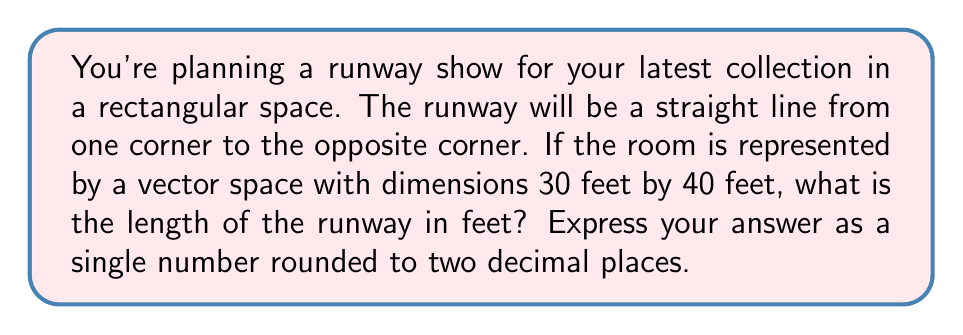Give your solution to this math problem. Let's approach this step-by-step using vector math:

1) First, we need to represent the room as a vector. The dimensions are 30 feet by 40 feet, so we can represent this as a vector:

   $\vec{v} = \begin{pmatrix} 30 \\ 40 \end{pmatrix}$

2) The runway goes from one corner to the opposite corner, which means it's the diagonal of this rectangle. In vector terms, this diagonal is exactly our vector $\vec{v}$.

3) To find the length of this diagonal (our runway), we need to calculate the magnitude of the vector $\vec{v}$. The magnitude of a vector is given by the square root of the sum of the squares of its components:

   $\|\vec{v}\| = \sqrt{x^2 + y^2}$

4) Plugging in our values:

   $\|\vec{v}\| = \sqrt{30^2 + 40^2}$

5) Let's calculate:

   $\|\vec{v}\| = \sqrt{900 + 1600} = \sqrt{2500} = 50$

6) Therefore, the length of the runway is 50 feet.

[asy]
import geometry;

size(200);
pair A=(0,0), B=(30,0), C=(30,40), D=(0,40);
draw(A--B--C--D--cycle);
draw(A--C,red);
label("30 ft",B,(0,-1),N);
label("40 ft",C,(1,0),E);
label("Runway",C/2,(1,1),NE);
[/asy]
Answer: 50.00 